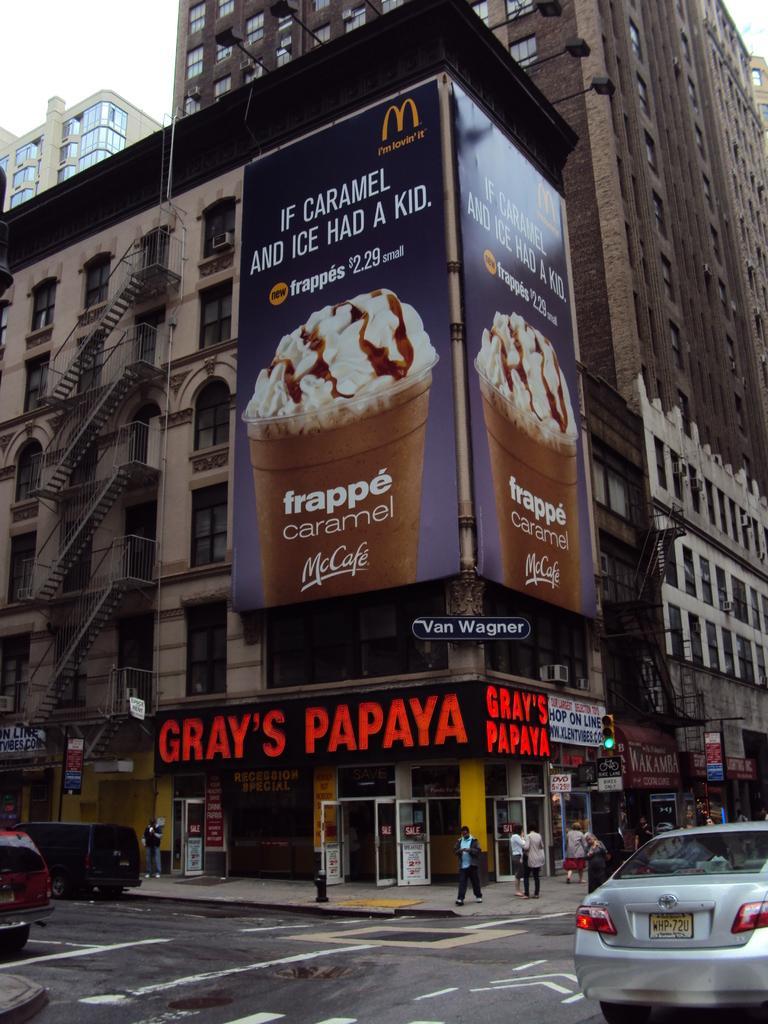In one or two sentences, can you explain what this image depicts? In this picture we can see group of people, few people are standing and few are walking on the pathway, in front of them we can see few vehicles on the road, in the background we can find traffic lights, hoardings, metal rods and buildings. 